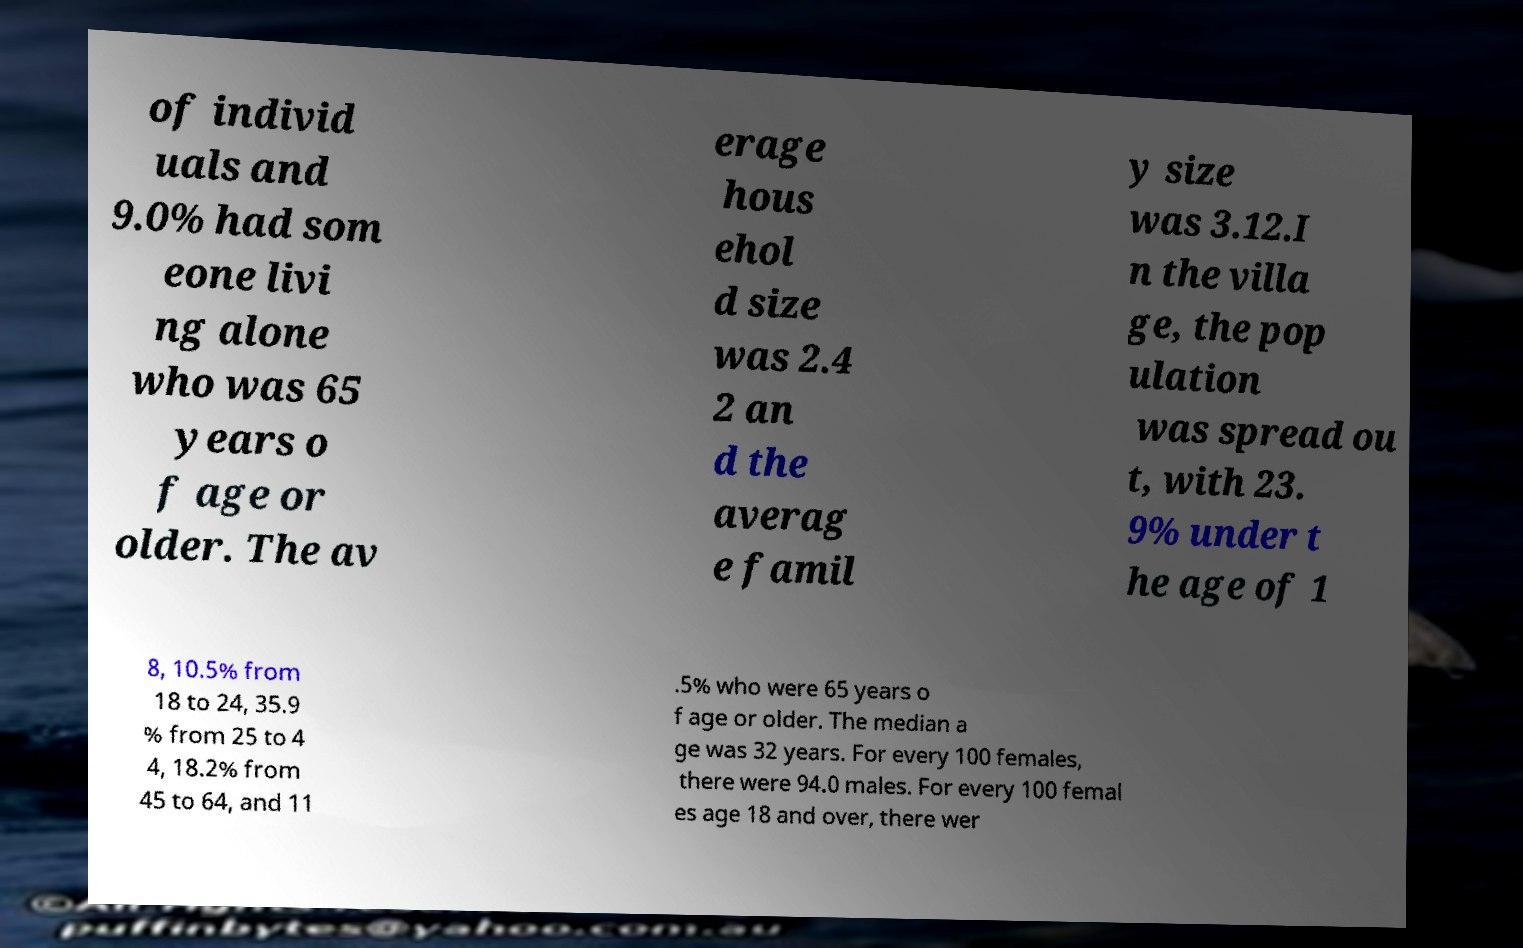Could you assist in decoding the text presented in this image and type it out clearly? of individ uals and 9.0% had som eone livi ng alone who was 65 years o f age or older. The av erage hous ehol d size was 2.4 2 an d the averag e famil y size was 3.12.I n the villa ge, the pop ulation was spread ou t, with 23. 9% under t he age of 1 8, 10.5% from 18 to 24, 35.9 % from 25 to 4 4, 18.2% from 45 to 64, and 11 .5% who were 65 years o f age or older. The median a ge was 32 years. For every 100 females, there were 94.0 males. For every 100 femal es age 18 and over, there wer 